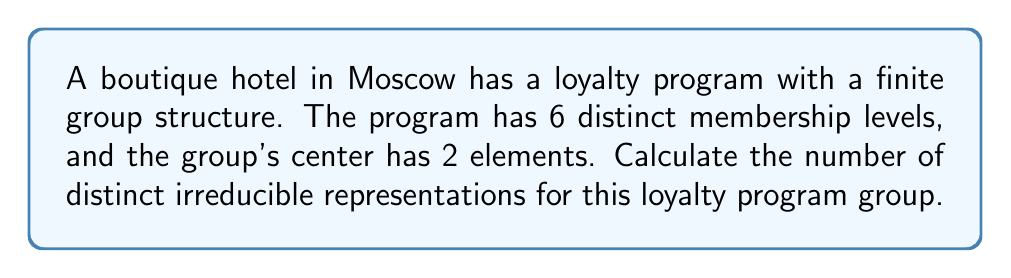Solve this math problem. Let's approach this step-by-step:

1) We are dealing with a finite group $G$. Let's denote:
   - $|G|$ as the order of the group (number of elements)
   - $k$ as the number of conjugacy classes
   - $Z(G)$ as the center of the group

2) Given information:
   - The group has 6 distinct membership levels, so $|G| = 6$
   - The center has 2 elements, so $|Z(G)| = 2$

3) A key theorem in representation theory states that for a finite group, the number of distinct irreducible representations is equal to the number of conjugacy classes.

4) To find the number of conjugacy classes, we can use the class equation:

   $$|G| = |Z(G)| + \sum_{i=1}^{r} [G : C_G(x_i)]$$

   where $r$ is the number of non-central conjugacy classes, and $C_G(x_i)$ is the centralizer of a representative $x_i$ from each non-central conjugacy class.

5) We know $|G| = 6$ and $|Z(G)| = 2$. So:

   $$6 = 2 + \sum_{i=1}^{r} [G : C_G(x_i)]$$

6) The only way to satisfy this equation is if there are 2 non-central conjugacy classes, each of size 2:

   $$6 = 2 + 2 + 2$$

7) Therefore, the total number of conjugacy classes $k$ is:
   - 2 (from the center) + 2 (non-central classes) = 4

8) Since the number of distinct irreducible representations equals the number of conjugacy classes, there are 4 distinct irreducible representations.
Answer: 4 